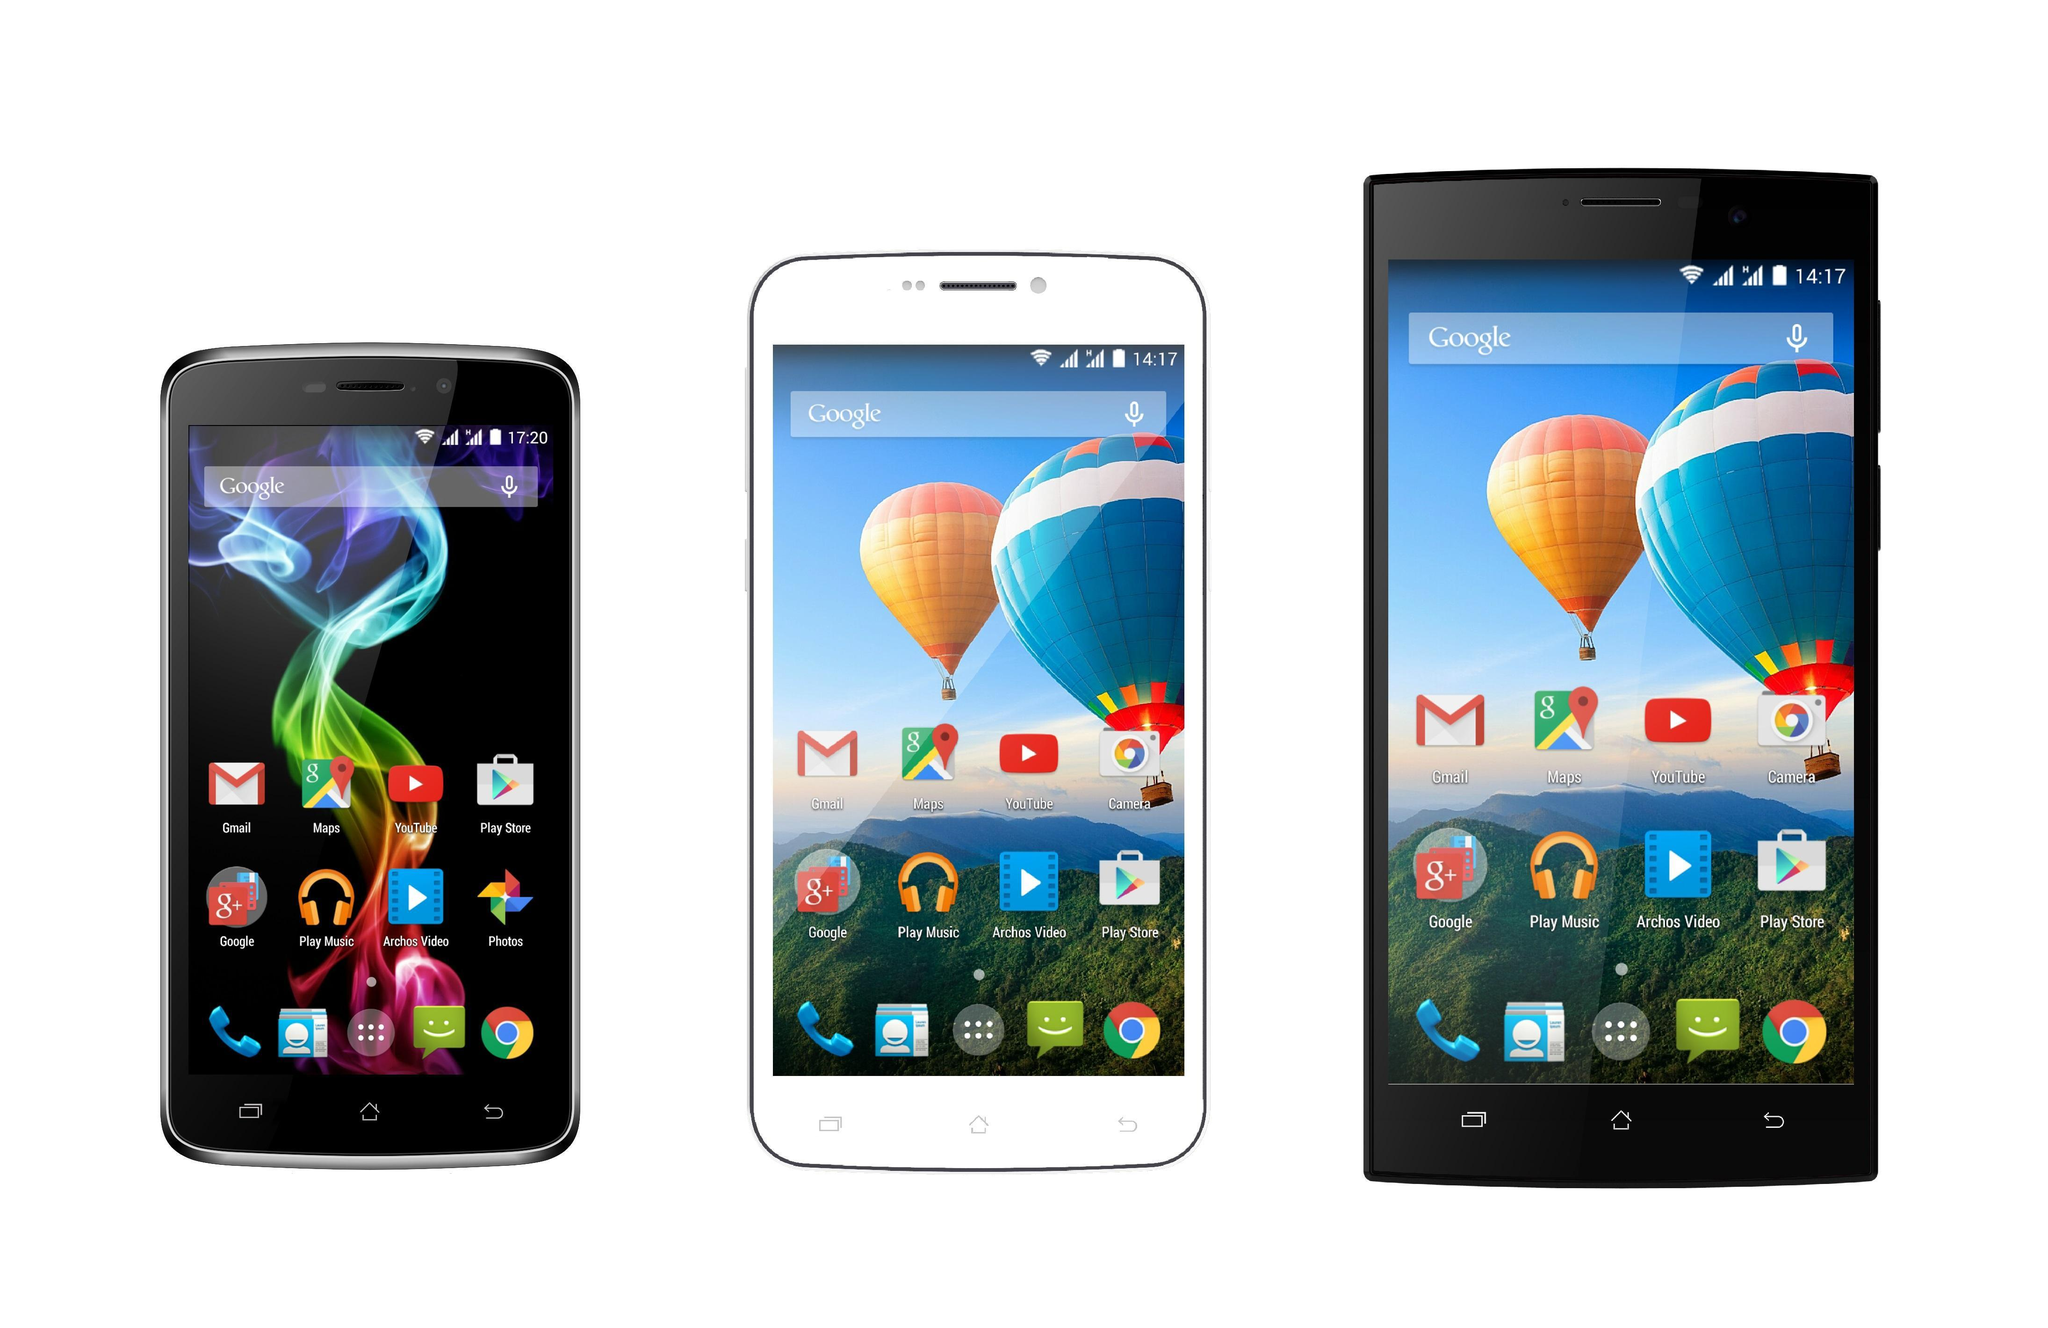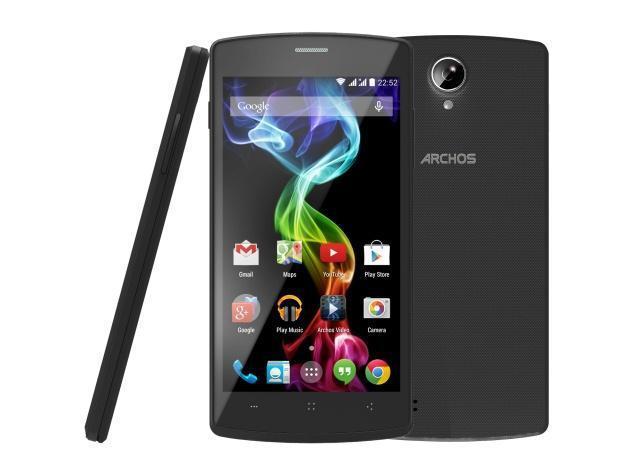The first image is the image on the left, the second image is the image on the right. For the images shown, is this caption "One of the phones has physical keys." true? Answer yes or no. No. The first image is the image on the left, the second image is the image on the right. Evaluate the accuracy of this statement regarding the images: "One image shows three screened devices in a row, and each image includes rainbow colors in a curving ribbon shape on at least one screen.". Is it true? Answer yes or no. Yes. 